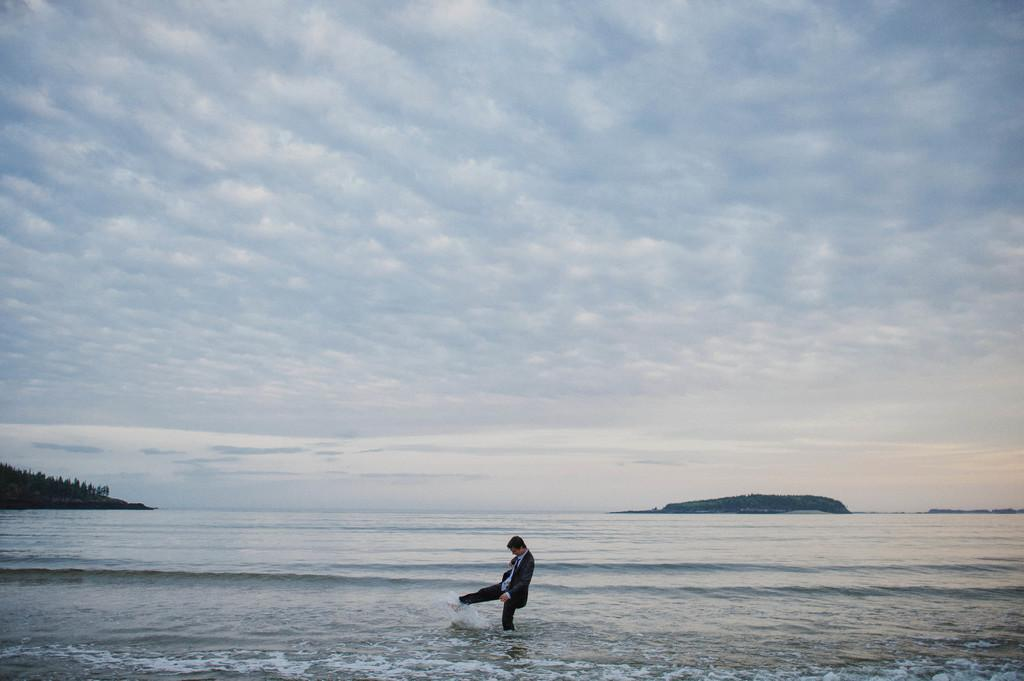What is in the foreground of the image? There is a water body in the foreground of the image. What is the person in the image doing? There is a person in the water in the image. What type of vegetation can be seen in the image? There are trees in the image. What is located on the right side of the image? There is an island on the right side of the image. What is visible at the top of the image? The sky is visible at the top of the image. How many aunts are present in the image? There are no aunts present in the image. What is the level of addition in the image? The concept of addition is not applicable to the image, as it is a visual representation of a scene and not a mathematical problem. 